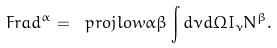<formula> <loc_0><loc_0><loc_500><loc_500>\ F r a d ^ { \alpha } = \ p r o j l o w { \alpha } { \beta } \int d \nu d \Omega I _ { \nu } N ^ { \beta } .</formula> 